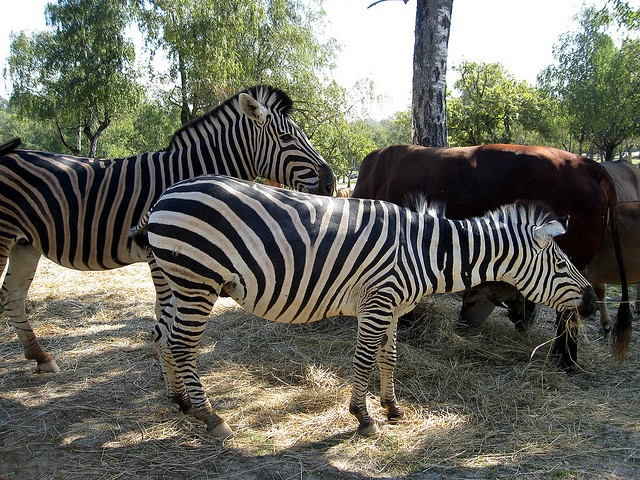Describe the objects in this image and their specific colors. I can see zebra in white, black, darkgray, and gray tones, zebra in white, black, gray, and darkgray tones, cow in white, black, gray, and maroon tones, and cow in white, black, and gray tones in this image. 